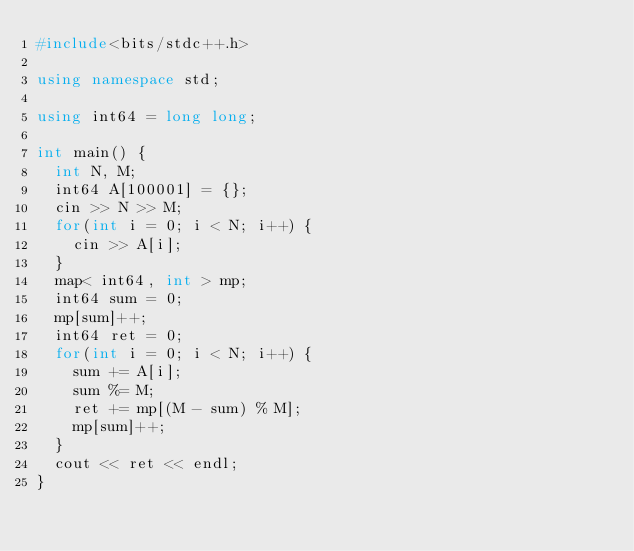Convert code to text. <code><loc_0><loc_0><loc_500><loc_500><_C++_>#include<bits/stdc++.h>

using namespace std;

using int64 = long long;

int main() {
  int N, M;
  int64 A[100001] = {};
  cin >> N >> M;
  for(int i = 0; i < N; i++) {
    cin >> A[i];
  }
  map< int64, int > mp;
  int64 sum = 0;
  mp[sum]++;
  int64 ret = 0;
  for(int i = 0; i < N; i++) {
    sum += A[i];
    sum %= M;
    ret += mp[(M - sum) % M];
    mp[sum]++;
  }
  cout << ret << endl;
}</code> 